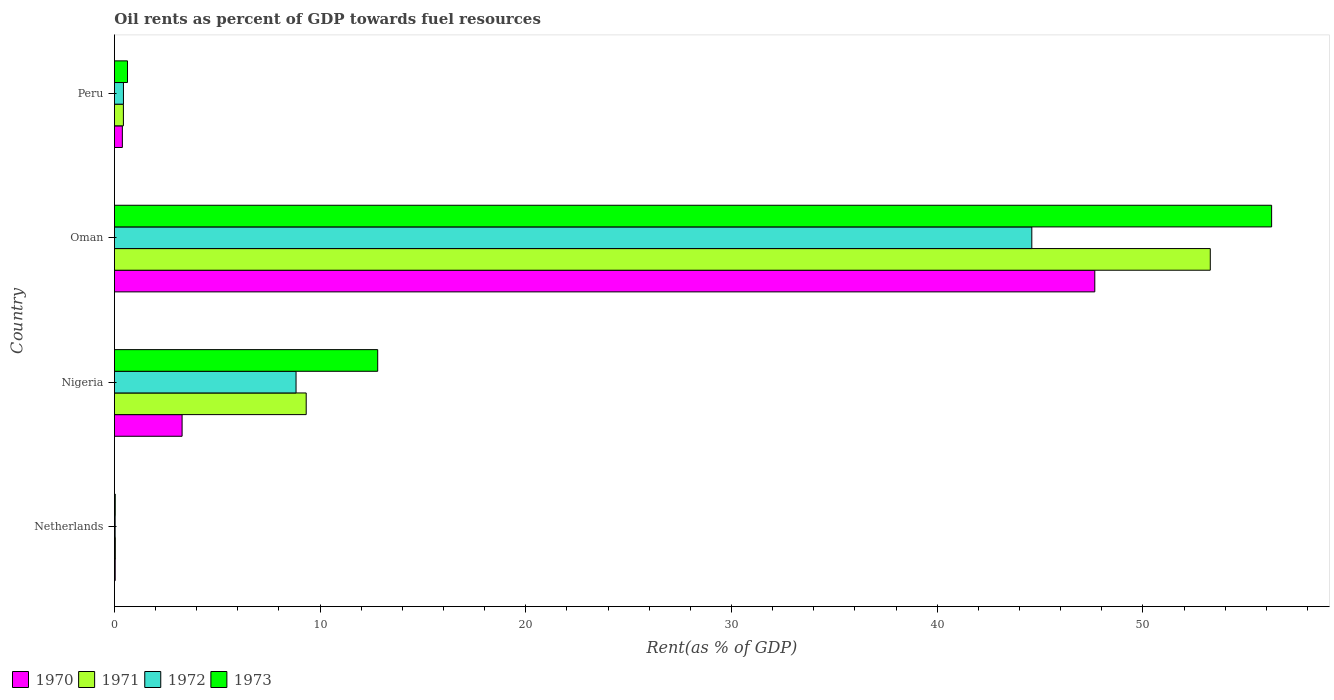Are the number of bars on each tick of the Y-axis equal?
Offer a terse response. Yes. How many bars are there on the 3rd tick from the top?
Keep it short and to the point. 4. What is the oil rent in 1973 in Peru?
Keep it short and to the point. 0.64. Across all countries, what is the maximum oil rent in 1971?
Offer a very short reply. 53.28. Across all countries, what is the minimum oil rent in 1970?
Offer a terse response. 0.04. In which country was the oil rent in 1973 maximum?
Your response must be concise. Oman. In which country was the oil rent in 1970 minimum?
Offer a terse response. Netherlands. What is the total oil rent in 1973 in the graph?
Your answer should be compact. 69.73. What is the difference between the oil rent in 1972 in Oman and that in Peru?
Give a very brief answer. 44.16. What is the difference between the oil rent in 1970 in Nigeria and the oil rent in 1973 in Netherlands?
Offer a very short reply. 3.25. What is the average oil rent in 1970 per country?
Provide a succinct answer. 12.84. What is the difference between the oil rent in 1972 and oil rent in 1970 in Netherlands?
Provide a succinct answer. -0. What is the ratio of the oil rent in 1971 in Nigeria to that in Oman?
Make the answer very short. 0.17. Is the difference between the oil rent in 1972 in Netherlands and Oman greater than the difference between the oil rent in 1970 in Netherlands and Oman?
Your response must be concise. Yes. What is the difference between the highest and the second highest oil rent in 1971?
Offer a terse response. 43.95. What is the difference between the highest and the lowest oil rent in 1973?
Provide a succinct answer. 56.22. In how many countries, is the oil rent in 1971 greater than the average oil rent in 1971 taken over all countries?
Give a very brief answer. 1. What does the 1st bar from the top in Peru represents?
Offer a terse response. 1973. Is it the case that in every country, the sum of the oil rent in 1972 and oil rent in 1970 is greater than the oil rent in 1971?
Offer a very short reply. Yes. How many bars are there?
Give a very brief answer. 16. Are all the bars in the graph horizontal?
Give a very brief answer. Yes. What is the difference between two consecutive major ticks on the X-axis?
Give a very brief answer. 10. How many legend labels are there?
Your answer should be very brief. 4. What is the title of the graph?
Your answer should be very brief. Oil rents as percent of GDP towards fuel resources. What is the label or title of the X-axis?
Offer a very short reply. Rent(as % of GDP). What is the Rent(as % of GDP) in 1970 in Netherlands?
Make the answer very short. 0.04. What is the Rent(as % of GDP) of 1971 in Netherlands?
Offer a terse response. 0.04. What is the Rent(as % of GDP) in 1972 in Netherlands?
Offer a terse response. 0.03. What is the Rent(as % of GDP) in 1973 in Netherlands?
Provide a succinct answer. 0.04. What is the Rent(as % of GDP) in 1970 in Nigeria?
Offer a terse response. 3.29. What is the Rent(as % of GDP) of 1971 in Nigeria?
Make the answer very short. 9.32. What is the Rent(as % of GDP) in 1972 in Nigeria?
Your response must be concise. 8.83. What is the Rent(as % of GDP) of 1973 in Nigeria?
Give a very brief answer. 12.8. What is the Rent(as % of GDP) of 1970 in Oman?
Your answer should be compact. 47.66. What is the Rent(as % of GDP) of 1971 in Oman?
Your answer should be very brief. 53.28. What is the Rent(as % of GDP) in 1972 in Oman?
Provide a short and direct response. 44.6. What is the Rent(as % of GDP) in 1973 in Oman?
Your answer should be compact. 56.26. What is the Rent(as % of GDP) of 1970 in Peru?
Make the answer very short. 0.39. What is the Rent(as % of GDP) of 1971 in Peru?
Your answer should be compact. 0.44. What is the Rent(as % of GDP) of 1972 in Peru?
Offer a terse response. 0.44. What is the Rent(as % of GDP) in 1973 in Peru?
Offer a very short reply. 0.64. Across all countries, what is the maximum Rent(as % of GDP) of 1970?
Provide a short and direct response. 47.66. Across all countries, what is the maximum Rent(as % of GDP) of 1971?
Ensure brevity in your answer.  53.28. Across all countries, what is the maximum Rent(as % of GDP) in 1972?
Your answer should be compact. 44.6. Across all countries, what is the maximum Rent(as % of GDP) of 1973?
Your answer should be compact. 56.26. Across all countries, what is the minimum Rent(as % of GDP) of 1970?
Ensure brevity in your answer.  0.04. Across all countries, what is the minimum Rent(as % of GDP) in 1971?
Your answer should be very brief. 0.04. Across all countries, what is the minimum Rent(as % of GDP) of 1972?
Provide a short and direct response. 0.03. Across all countries, what is the minimum Rent(as % of GDP) of 1973?
Provide a succinct answer. 0.04. What is the total Rent(as % of GDP) in 1970 in the graph?
Your answer should be compact. 51.38. What is the total Rent(as % of GDP) in 1971 in the graph?
Ensure brevity in your answer.  63.08. What is the total Rent(as % of GDP) in 1972 in the graph?
Keep it short and to the point. 53.9. What is the total Rent(as % of GDP) in 1973 in the graph?
Your answer should be compact. 69.73. What is the difference between the Rent(as % of GDP) of 1970 in Netherlands and that in Nigeria?
Provide a short and direct response. -3.25. What is the difference between the Rent(as % of GDP) of 1971 in Netherlands and that in Nigeria?
Provide a short and direct response. -9.28. What is the difference between the Rent(as % of GDP) in 1972 in Netherlands and that in Nigeria?
Your response must be concise. -8.79. What is the difference between the Rent(as % of GDP) in 1973 in Netherlands and that in Nigeria?
Provide a short and direct response. -12.76. What is the difference between the Rent(as % of GDP) of 1970 in Netherlands and that in Oman?
Your response must be concise. -47.62. What is the difference between the Rent(as % of GDP) in 1971 in Netherlands and that in Oman?
Your answer should be very brief. -53.23. What is the difference between the Rent(as % of GDP) of 1972 in Netherlands and that in Oman?
Your answer should be compact. -44.57. What is the difference between the Rent(as % of GDP) in 1973 in Netherlands and that in Oman?
Ensure brevity in your answer.  -56.22. What is the difference between the Rent(as % of GDP) of 1970 in Netherlands and that in Peru?
Give a very brief answer. -0.35. What is the difference between the Rent(as % of GDP) in 1971 in Netherlands and that in Peru?
Make the answer very short. -0.39. What is the difference between the Rent(as % of GDP) in 1972 in Netherlands and that in Peru?
Keep it short and to the point. -0.4. What is the difference between the Rent(as % of GDP) in 1973 in Netherlands and that in Peru?
Provide a succinct answer. -0.6. What is the difference between the Rent(as % of GDP) in 1970 in Nigeria and that in Oman?
Give a very brief answer. -44.37. What is the difference between the Rent(as % of GDP) in 1971 in Nigeria and that in Oman?
Offer a very short reply. -43.95. What is the difference between the Rent(as % of GDP) in 1972 in Nigeria and that in Oman?
Offer a very short reply. -35.77. What is the difference between the Rent(as % of GDP) of 1973 in Nigeria and that in Oman?
Your response must be concise. -43.46. What is the difference between the Rent(as % of GDP) in 1970 in Nigeria and that in Peru?
Give a very brief answer. 2.9. What is the difference between the Rent(as % of GDP) of 1971 in Nigeria and that in Peru?
Provide a short and direct response. 8.89. What is the difference between the Rent(as % of GDP) in 1972 in Nigeria and that in Peru?
Your answer should be compact. 8.39. What is the difference between the Rent(as % of GDP) of 1973 in Nigeria and that in Peru?
Make the answer very short. 12.16. What is the difference between the Rent(as % of GDP) of 1970 in Oman and that in Peru?
Provide a succinct answer. 47.28. What is the difference between the Rent(as % of GDP) of 1971 in Oman and that in Peru?
Your answer should be very brief. 52.84. What is the difference between the Rent(as % of GDP) in 1972 in Oman and that in Peru?
Ensure brevity in your answer.  44.16. What is the difference between the Rent(as % of GDP) in 1973 in Oman and that in Peru?
Keep it short and to the point. 55.62. What is the difference between the Rent(as % of GDP) of 1970 in Netherlands and the Rent(as % of GDP) of 1971 in Nigeria?
Your response must be concise. -9.29. What is the difference between the Rent(as % of GDP) of 1970 in Netherlands and the Rent(as % of GDP) of 1972 in Nigeria?
Your answer should be compact. -8.79. What is the difference between the Rent(as % of GDP) of 1970 in Netherlands and the Rent(as % of GDP) of 1973 in Nigeria?
Provide a short and direct response. -12.76. What is the difference between the Rent(as % of GDP) in 1971 in Netherlands and the Rent(as % of GDP) in 1972 in Nigeria?
Keep it short and to the point. -8.79. What is the difference between the Rent(as % of GDP) in 1971 in Netherlands and the Rent(as % of GDP) in 1973 in Nigeria?
Offer a terse response. -12.76. What is the difference between the Rent(as % of GDP) in 1972 in Netherlands and the Rent(as % of GDP) in 1973 in Nigeria?
Ensure brevity in your answer.  -12.76. What is the difference between the Rent(as % of GDP) in 1970 in Netherlands and the Rent(as % of GDP) in 1971 in Oman?
Offer a very short reply. -53.24. What is the difference between the Rent(as % of GDP) in 1970 in Netherlands and the Rent(as % of GDP) in 1972 in Oman?
Keep it short and to the point. -44.56. What is the difference between the Rent(as % of GDP) in 1970 in Netherlands and the Rent(as % of GDP) in 1973 in Oman?
Your response must be concise. -56.22. What is the difference between the Rent(as % of GDP) in 1971 in Netherlands and the Rent(as % of GDP) in 1972 in Oman?
Make the answer very short. -44.56. What is the difference between the Rent(as % of GDP) in 1971 in Netherlands and the Rent(as % of GDP) in 1973 in Oman?
Make the answer very short. -56.22. What is the difference between the Rent(as % of GDP) of 1972 in Netherlands and the Rent(as % of GDP) of 1973 in Oman?
Keep it short and to the point. -56.22. What is the difference between the Rent(as % of GDP) in 1970 in Netherlands and the Rent(as % of GDP) in 1971 in Peru?
Give a very brief answer. -0.4. What is the difference between the Rent(as % of GDP) of 1970 in Netherlands and the Rent(as % of GDP) of 1972 in Peru?
Offer a very short reply. -0.4. What is the difference between the Rent(as % of GDP) in 1970 in Netherlands and the Rent(as % of GDP) in 1973 in Peru?
Your response must be concise. -0.6. What is the difference between the Rent(as % of GDP) in 1971 in Netherlands and the Rent(as % of GDP) in 1972 in Peru?
Keep it short and to the point. -0.4. What is the difference between the Rent(as % of GDP) of 1971 in Netherlands and the Rent(as % of GDP) of 1973 in Peru?
Your answer should be compact. -0.59. What is the difference between the Rent(as % of GDP) of 1972 in Netherlands and the Rent(as % of GDP) of 1973 in Peru?
Offer a very short reply. -0.6. What is the difference between the Rent(as % of GDP) in 1970 in Nigeria and the Rent(as % of GDP) in 1971 in Oman?
Your response must be concise. -49.99. What is the difference between the Rent(as % of GDP) in 1970 in Nigeria and the Rent(as % of GDP) in 1972 in Oman?
Offer a terse response. -41.31. What is the difference between the Rent(as % of GDP) in 1970 in Nigeria and the Rent(as % of GDP) in 1973 in Oman?
Make the answer very short. -52.97. What is the difference between the Rent(as % of GDP) in 1971 in Nigeria and the Rent(as % of GDP) in 1972 in Oman?
Provide a succinct answer. -35.28. What is the difference between the Rent(as % of GDP) in 1971 in Nigeria and the Rent(as % of GDP) in 1973 in Oman?
Ensure brevity in your answer.  -46.94. What is the difference between the Rent(as % of GDP) of 1972 in Nigeria and the Rent(as % of GDP) of 1973 in Oman?
Provide a succinct answer. -47.43. What is the difference between the Rent(as % of GDP) of 1970 in Nigeria and the Rent(as % of GDP) of 1971 in Peru?
Offer a very short reply. 2.85. What is the difference between the Rent(as % of GDP) in 1970 in Nigeria and the Rent(as % of GDP) in 1972 in Peru?
Make the answer very short. 2.85. What is the difference between the Rent(as % of GDP) of 1970 in Nigeria and the Rent(as % of GDP) of 1973 in Peru?
Give a very brief answer. 2.65. What is the difference between the Rent(as % of GDP) in 1971 in Nigeria and the Rent(as % of GDP) in 1972 in Peru?
Ensure brevity in your answer.  8.88. What is the difference between the Rent(as % of GDP) of 1971 in Nigeria and the Rent(as % of GDP) of 1973 in Peru?
Give a very brief answer. 8.69. What is the difference between the Rent(as % of GDP) of 1972 in Nigeria and the Rent(as % of GDP) of 1973 in Peru?
Offer a terse response. 8.19. What is the difference between the Rent(as % of GDP) in 1970 in Oman and the Rent(as % of GDP) in 1971 in Peru?
Your response must be concise. 47.23. What is the difference between the Rent(as % of GDP) of 1970 in Oman and the Rent(as % of GDP) of 1972 in Peru?
Offer a terse response. 47.22. What is the difference between the Rent(as % of GDP) in 1970 in Oman and the Rent(as % of GDP) in 1973 in Peru?
Offer a terse response. 47.03. What is the difference between the Rent(as % of GDP) in 1971 in Oman and the Rent(as % of GDP) in 1972 in Peru?
Your response must be concise. 52.84. What is the difference between the Rent(as % of GDP) in 1971 in Oman and the Rent(as % of GDP) in 1973 in Peru?
Provide a succinct answer. 52.64. What is the difference between the Rent(as % of GDP) of 1972 in Oman and the Rent(as % of GDP) of 1973 in Peru?
Your answer should be very brief. 43.96. What is the average Rent(as % of GDP) of 1970 per country?
Make the answer very short. 12.84. What is the average Rent(as % of GDP) of 1971 per country?
Your response must be concise. 15.77. What is the average Rent(as % of GDP) in 1972 per country?
Your response must be concise. 13.48. What is the average Rent(as % of GDP) in 1973 per country?
Keep it short and to the point. 17.43. What is the difference between the Rent(as % of GDP) of 1970 and Rent(as % of GDP) of 1971 in Netherlands?
Make the answer very short. -0.01. What is the difference between the Rent(as % of GDP) in 1970 and Rent(as % of GDP) in 1972 in Netherlands?
Keep it short and to the point. 0. What is the difference between the Rent(as % of GDP) in 1970 and Rent(as % of GDP) in 1973 in Netherlands?
Your response must be concise. -0. What is the difference between the Rent(as % of GDP) of 1971 and Rent(as % of GDP) of 1972 in Netherlands?
Give a very brief answer. 0.01. What is the difference between the Rent(as % of GDP) of 1971 and Rent(as % of GDP) of 1973 in Netherlands?
Offer a terse response. 0. What is the difference between the Rent(as % of GDP) in 1972 and Rent(as % of GDP) in 1973 in Netherlands?
Provide a short and direct response. -0. What is the difference between the Rent(as % of GDP) of 1970 and Rent(as % of GDP) of 1971 in Nigeria?
Offer a very short reply. -6.03. What is the difference between the Rent(as % of GDP) of 1970 and Rent(as % of GDP) of 1972 in Nigeria?
Your response must be concise. -5.54. What is the difference between the Rent(as % of GDP) of 1970 and Rent(as % of GDP) of 1973 in Nigeria?
Give a very brief answer. -9.51. What is the difference between the Rent(as % of GDP) of 1971 and Rent(as % of GDP) of 1972 in Nigeria?
Give a very brief answer. 0.49. What is the difference between the Rent(as % of GDP) of 1971 and Rent(as % of GDP) of 1973 in Nigeria?
Offer a very short reply. -3.48. What is the difference between the Rent(as % of GDP) in 1972 and Rent(as % of GDP) in 1973 in Nigeria?
Ensure brevity in your answer.  -3.97. What is the difference between the Rent(as % of GDP) in 1970 and Rent(as % of GDP) in 1971 in Oman?
Give a very brief answer. -5.61. What is the difference between the Rent(as % of GDP) of 1970 and Rent(as % of GDP) of 1972 in Oman?
Your response must be concise. 3.06. What is the difference between the Rent(as % of GDP) of 1970 and Rent(as % of GDP) of 1973 in Oman?
Your response must be concise. -8.6. What is the difference between the Rent(as % of GDP) in 1971 and Rent(as % of GDP) in 1972 in Oman?
Provide a succinct answer. 8.68. What is the difference between the Rent(as % of GDP) of 1971 and Rent(as % of GDP) of 1973 in Oman?
Give a very brief answer. -2.98. What is the difference between the Rent(as % of GDP) of 1972 and Rent(as % of GDP) of 1973 in Oman?
Provide a short and direct response. -11.66. What is the difference between the Rent(as % of GDP) of 1970 and Rent(as % of GDP) of 1971 in Peru?
Offer a terse response. -0.05. What is the difference between the Rent(as % of GDP) of 1970 and Rent(as % of GDP) of 1972 in Peru?
Ensure brevity in your answer.  -0.05. What is the difference between the Rent(as % of GDP) of 1970 and Rent(as % of GDP) of 1973 in Peru?
Make the answer very short. -0.25. What is the difference between the Rent(as % of GDP) of 1971 and Rent(as % of GDP) of 1972 in Peru?
Provide a succinct answer. -0. What is the difference between the Rent(as % of GDP) of 1971 and Rent(as % of GDP) of 1973 in Peru?
Offer a terse response. -0.2. What is the difference between the Rent(as % of GDP) of 1972 and Rent(as % of GDP) of 1973 in Peru?
Give a very brief answer. -0.2. What is the ratio of the Rent(as % of GDP) of 1970 in Netherlands to that in Nigeria?
Keep it short and to the point. 0.01. What is the ratio of the Rent(as % of GDP) in 1971 in Netherlands to that in Nigeria?
Make the answer very short. 0. What is the ratio of the Rent(as % of GDP) in 1972 in Netherlands to that in Nigeria?
Ensure brevity in your answer.  0. What is the ratio of the Rent(as % of GDP) in 1973 in Netherlands to that in Nigeria?
Your response must be concise. 0. What is the ratio of the Rent(as % of GDP) in 1970 in Netherlands to that in Oman?
Your answer should be compact. 0. What is the ratio of the Rent(as % of GDP) of 1971 in Netherlands to that in Oman?
Keep it short and to the point. 0. What is the ratio of the Rent(as % of GDP) of 1972 in Netherlands to that in Oman?
Offer a very short reply. 0. What is the ratio of the Rent(as % of GDP) of 1973 in Netherlands to that in Oman?
Make the answer very short. 0. What is the ratio of the Rent(as % of GDP) of 1970 in Netherlands to that in Peru?
Keep it short and to the point. 0.1. What is the ratio of the Rent(as % of GDP) in 1971 in Netherlands to that in Peru?
Ensure brevity in your answer.  0.1. What is the ratio of the Rent(as % of GDP) in 1972 in Netherlands to that in Peru?
Offer a terse response. 0.08. What is the ratio of the Rent(as % of GDP) in 1973 in Netherlands to that in Peru?
Provide a succinct answer. 0.06. What is the ratio of the Rent(as % of GDP) in 1970 in Nigeria to that in Oman?
Offer a terse response. 0.07. What is the ratio of the Rent(as % of GDP) of 1971 in Nigeria to that in Oman?
Your response must be concise. 0.17. What is the ratio of the Rent(as % of GDP) in 1972 in Nigeria to that in Oman?
Offer a terse response. 0.2. What is the ratio of the Rent(as % of GDP) of 1973 in Nigeria to that in Oman?
Ensure brevity in your answer.  0.23. What is the ratio of the Rent(as % of GDP) of 1970 in Nigeria to that in Peru?
Your answer should be very brief. 8.53. What is the ratio of the Rent(as % of GDP) of 1971 in Nigeria to that in Peru?
Provide a succinct answer. 21.35. What is the ratio of the Rent(as % of GDP) of 1972 in Nigeria to that in Peru?
Provide a succinct answer. 20.12. What is the ratio of the Rent(as % of GDP) of 1973 in Nigeria to that in Peru?
Provide a succinct answer. 20.13. What is the ratio of the Rent(as % of GDP) of 1970 in Oman to that in Peru?
Your response must be concise. 123.65. What is the ratio of the Rent(as % of GDP) of 1971 in Oman to that in Peru?
Your response must be concise. 121.98. What is the ratio of the Rent(as % of GDP) in 1972 in Oman to that in Peru?
Ensure brevity in your answer.  101.64. What is the ratio of the Rent(as % of GDP) of 1973 in Oman to that in Peru?
Your answer should be compact. 88.49. What is the difference between the highest and the second highest Rent(as % of GDP) in 1970?
Your answer should be very brief. 44.37. What is the difference between the highest and the second highest Rent(as % of GDP) of 1971?
Provide a succinct answer. 43.95. What is the difference between the highest and the second highest Rent(as % of GDP) of 1972?
Make the answer very short. 35.77. What is the difference between the highest and the second highest Rent(as % of GDP) in 1973?
Keep it short and to the point. 43.46. What is the difference between the highest and the lowest Rent(as % of GDP) of 1970?
Your answer should be compact. 47.62. What is the difference between the highest and the lowest Rent(as % of GDP) in 1971?
Keep it short and to the point. 53.23. What is the difference between the highest and the lowest Rent(as % of GDP) of 1972?
Ensure brevity in your answer.  44.57. What is the difference between the highest and the lowest Rent(as % of GDP) in 1973?
Make the answer very short. 56.22. 